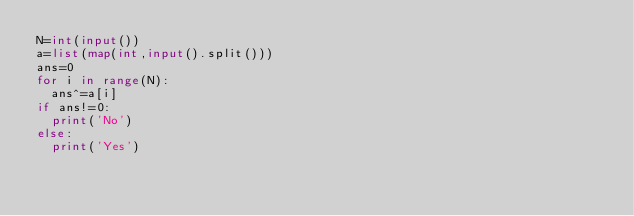<code> <loc_0><loc_0><loc_500><loc_500><_Python_>N=int(input())
a=list(map(int,input().split()))
ans=0
for i in range(N):
  ans^=a[i]
if ans!=0:
  print('No')
else:
  print('Yes')</code> 